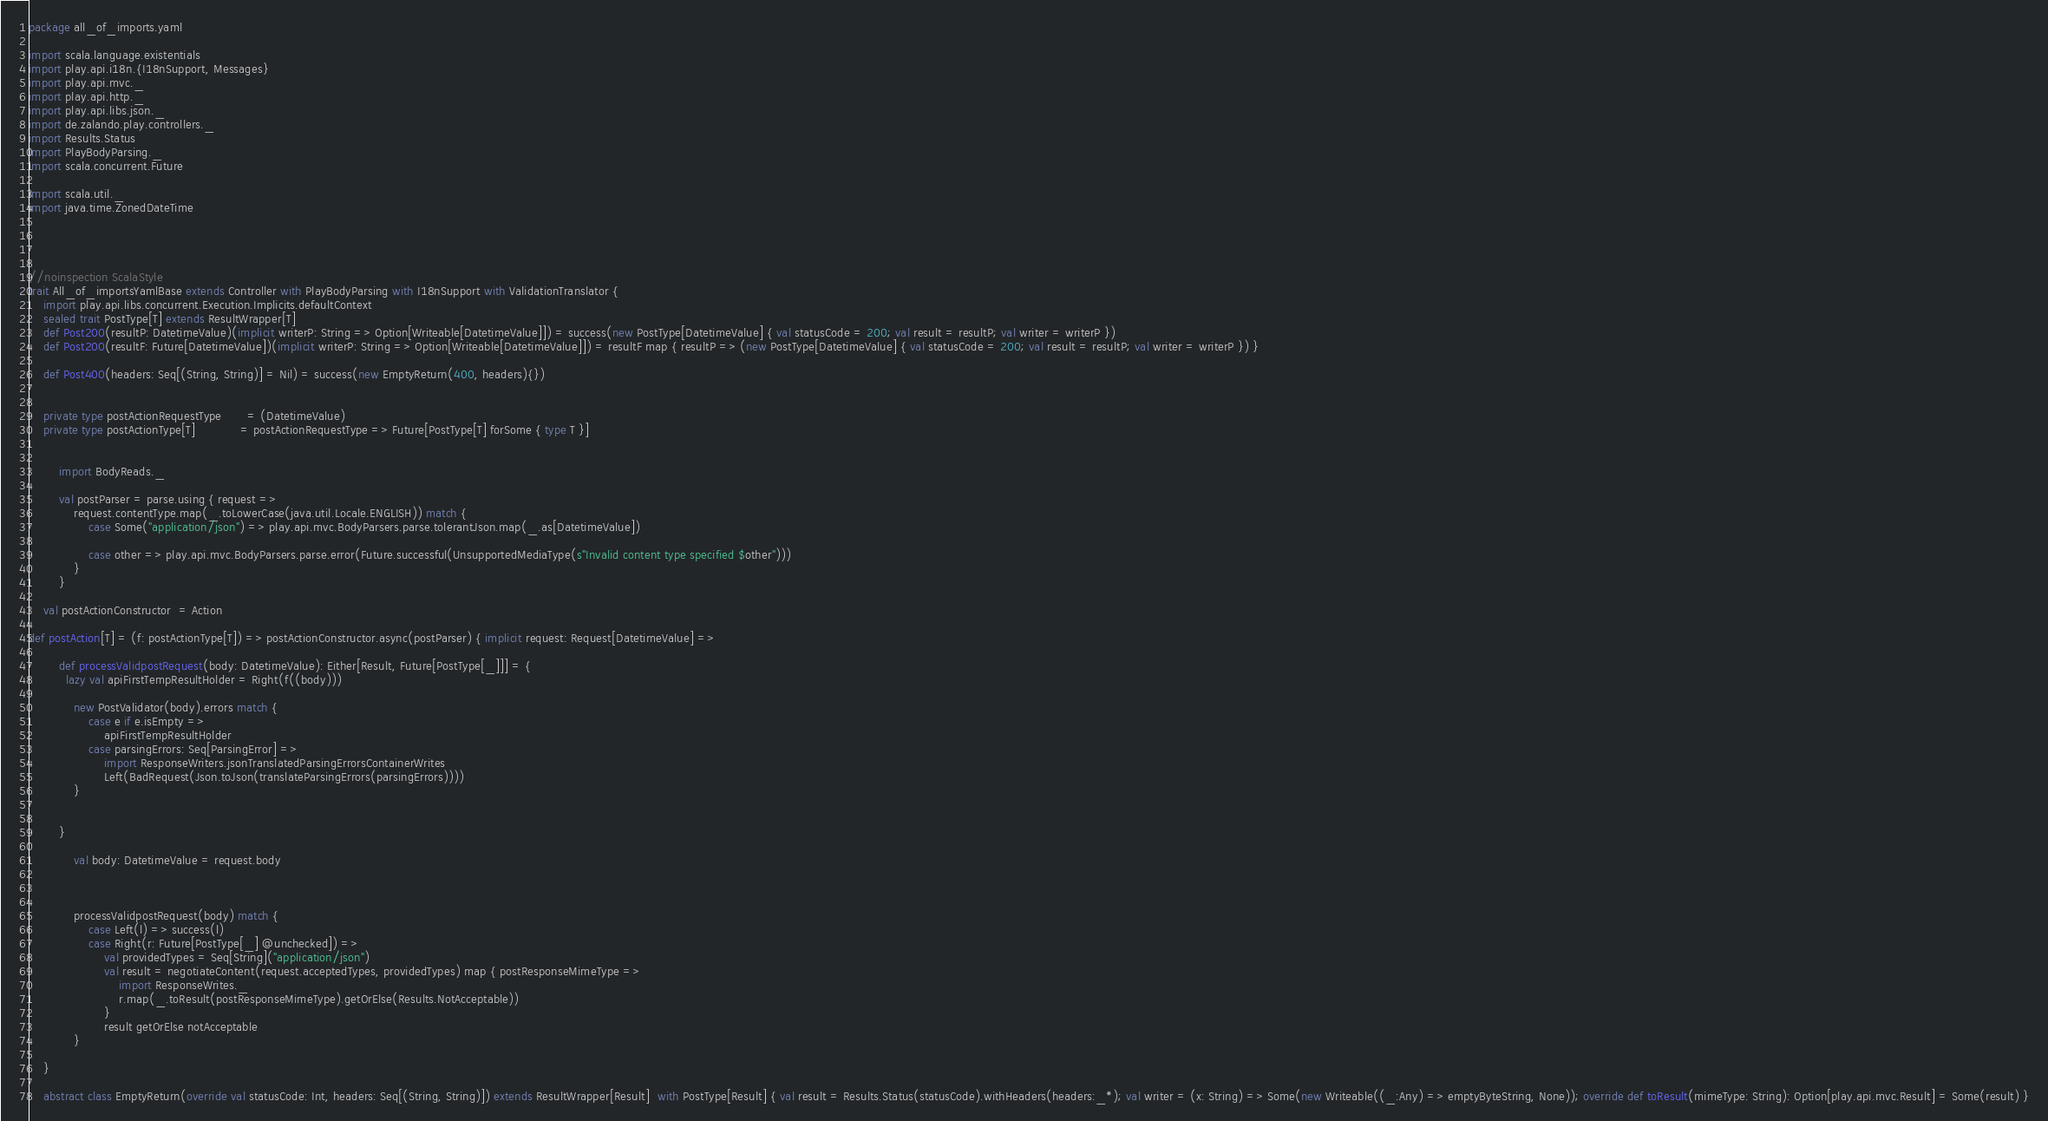Convert code to text. <code><loc_0><loc_0><loc_500><loc_500><_Scala_>package all_of_imports.yaml

import scala.language.existentials
import play.api.i18n.{I18nSupport, Messages}
import play.api.mvc._
import play.api.http._
import play.api.libs.json._
import de.zalando.play.controllers._
import Results.Status
import PlayBodyParsing._
import scala.concurrent.Future

import scala.util._
import java.time.ZonedDateTime




//noinspection ScalaStyle
trait All_of_importsYamlBase extends Controller with PlayBodyParsing with I18nSupport with ValidationTranslator {
    import play.api.libs.concurrent.Execution.Implicits.defaultContext
    sealed trait PostType[T] extends ResultWrapper[T]
    def Post200(resultP: DatetimeValue)(implicit writerP: String => Option[Writeable[DatetimeValue]]) = success(new PostType[DatetimeValue] { val statusCode = 200; val result = resultP; val writer = writerP })
    def Post200(resultF: Future[DatetimeValue])(implicit writerP: String => Option[Writeable[DatetimeValue]]) = resultF map { resultP => (new PostType[DatetimeValue] { val statusCode = 200; val result = resultP; val writer = writerP }) }
    
    def Post400(headers: Seq[(String, String)] = Nil) = success(new EmptyReturn(400, headers){})
    

    private type postActionRequestType       = (DatetimeValue)
    private type postActionType[T]            = postActionRequestType => Future[PostType[T] forSome { type T }]

        
        import BodyReads._
        
        val postParser = parse.using { request =>
            request.contentType.map(_.toLowerCase(java.util.Locale.ENGLISH)) match {
                case Some("application/json") => play.api.mvc.BodyParsers.parse.tolerantJson.map(_.as[DatetimeValue])
                
                case other => play.api.mvc.BodyParsers.parse.error(Future.successful(UnsupportedMediaType(s"Invalid content type specified $other")))
            }
        }

    val postActionConstructor  = Action

def postAction[T] = (f: postActionType[T]) => postActionConstructor.async(postParser) { implicit request: Request[DatetimeValue] =>

        def processValidpostRequest(body: DatetimeValue): Either[Result, Future[PostType[_]]] = {
          lazy val apiFirstTempResultHolder = Right(f((body)))
            
            new PostValidator(body).errors match {
                case e if e.isEmpty =>
                    apiFirstTempResultHolder
                case parsingErrors: Seq[ParsingError] =>
                    import ResponseWriters.jsonTranslatedParsingErrorsContainerWrites
                    Left(BadRequest(Json.toJson(translateParsingErrors(parsingErrors))))
            }
            
          
        }

            val body: DatetimeValue = request.body
            
            

            processValidpostRequest(body) match {
                case Left(l) => success(l)
                case Right(r: Future[PostType[_] @unchecked]) =>
                    val providedTypes = Seq[String]("application/json")
                    val result = negotiateContent(request.acceptedTypes, providedTypes) map { postResponseMimeType =>
                        import ResponseWrites._
                        r.map(_.toResult(postResponseMimeType).getOrElse(Results.NotAcceptable))
                    }
                    result getOrElse notAcceptable
            }
            
    }

    abstract class EmptyReturn(override val statusCode: Int, headers: Seq[(String, String)]) extends ResultWrapper[Result]  with PostType[Result] { val result = Results.Status(statusCode).withHeaders(headers:_*); val writer = (x: String) => Some(new Writeable((_:Any) => emptyByteString, None)); override def toResult(mimeType: String): Option[play.api.mvc.Result] = Some(result) }</code> 